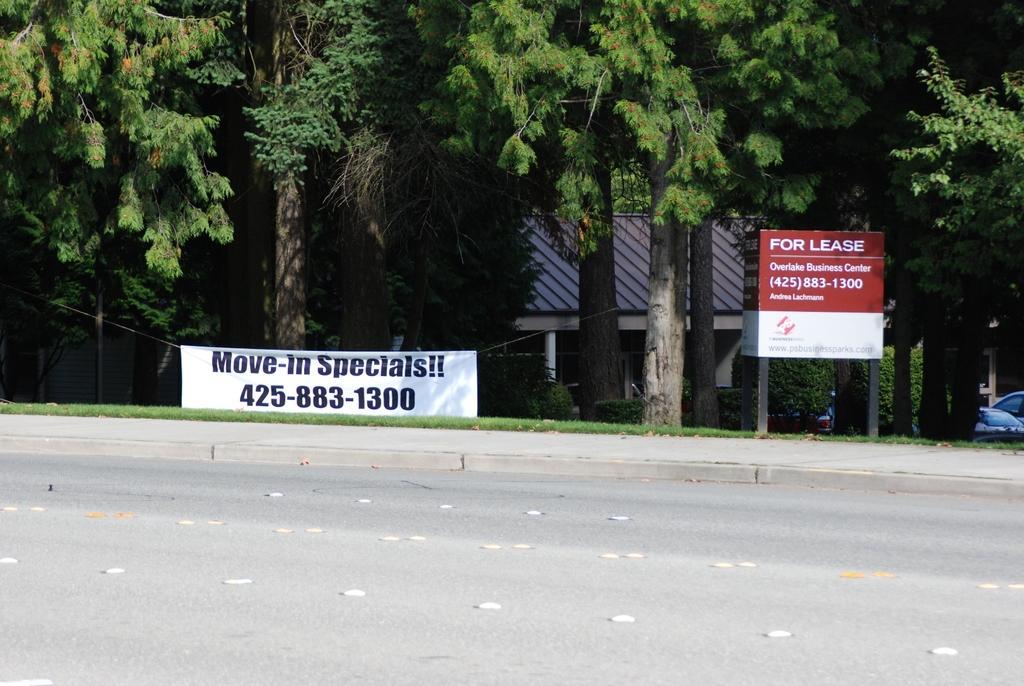In one or two sentences, can you explain what this image depicts? In this picture we can see the road, banner, grass, trees, houses, vehicles, posters on a stand. 